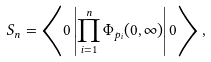Convert formula to latex. <formula><loc_0><loc_0><loc_500><loc_500>S _ { n } = \left \langle 0 \left | \prod _ { i = 1 } ^ { n } \Phi _ { p _ { i } } ( 0 , \infty ) \right | 0 \right \rangle ,</formula> 